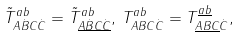Convert formula to latex. <formula><loc_0><loc_0><loc_500><loc_500>\tilde { T } _ { A \dot { B } C \dot { C } } ^ { a b } = \tilde { T } _ { \underline { A } \underline { \dot { B } } \underline { C } \underline { \dot { C } } } ^ { a b } , \, T _ { A B C \dot { C } } ^ { a b } = T _ { \underline { A } \underline { B } \underline { C } \dot { C } } ^ { \underline { a } \underline { b } } ,</formula> 